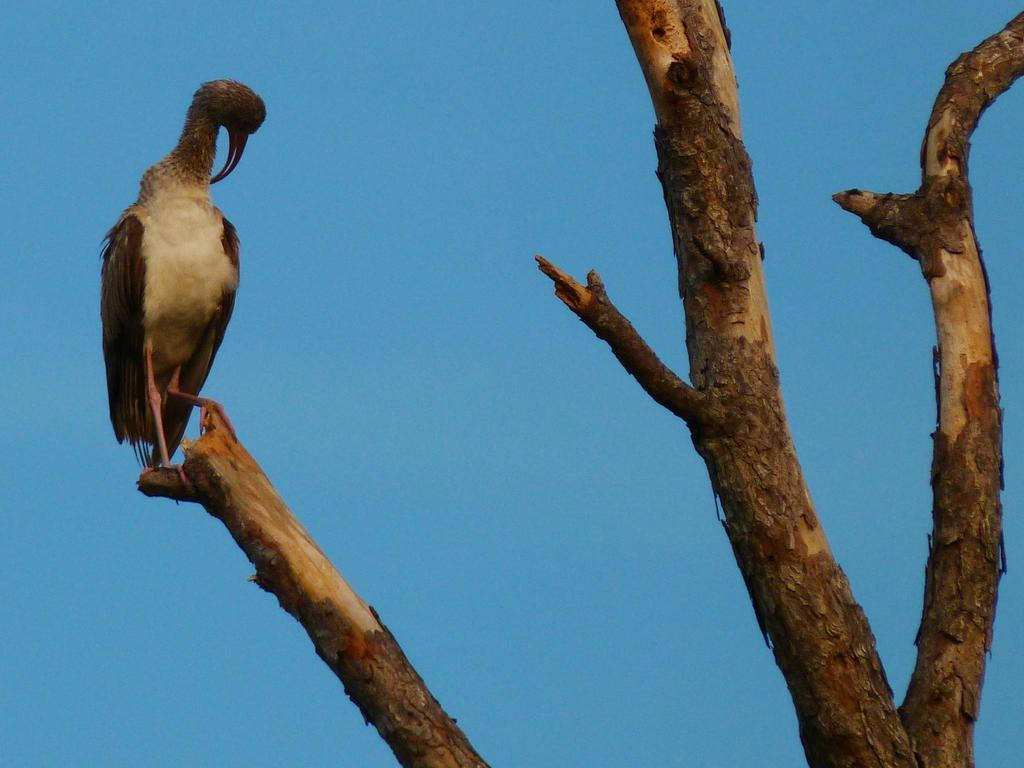What type of animal can be seen in the image? There is a bird in the image. Where is the bird located? The bird is sitting on a tree. What is the color of the sky in the image? The sky is blue in color. Can you see a trail of footprints left by the bird in the image? There is no trail of footprints visible in the image. 